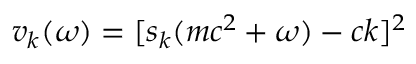Convert formula to latex. <formula><loc_0><loc_0><loc_500><loc_500>v _ { k } ( \omega ) = [ s _ { k } ( m c ^ { 2 } + \omega ) - c k ] ^ { 2 }</formula> 